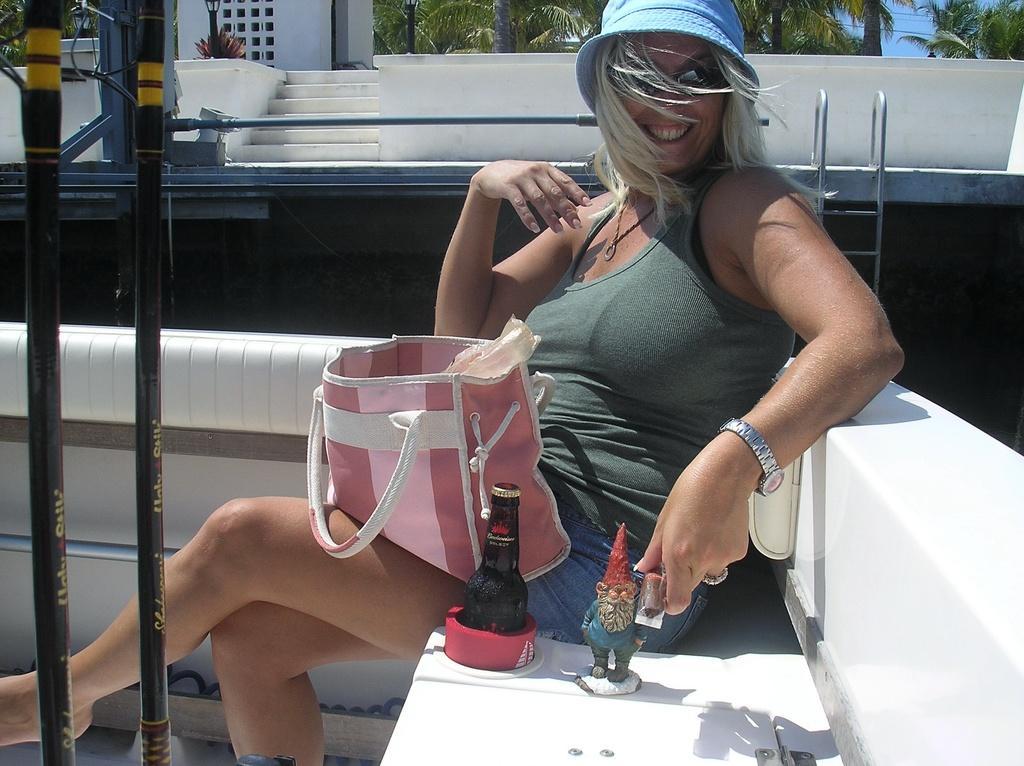Can you describe this image briefly? In this image I can see a woman sit on the bench and holding hand bag and there are the some bottles and idols kept on the bench , in the background there is a sky and trees visible and there are pipe lines on the left side ,she is smiling. 